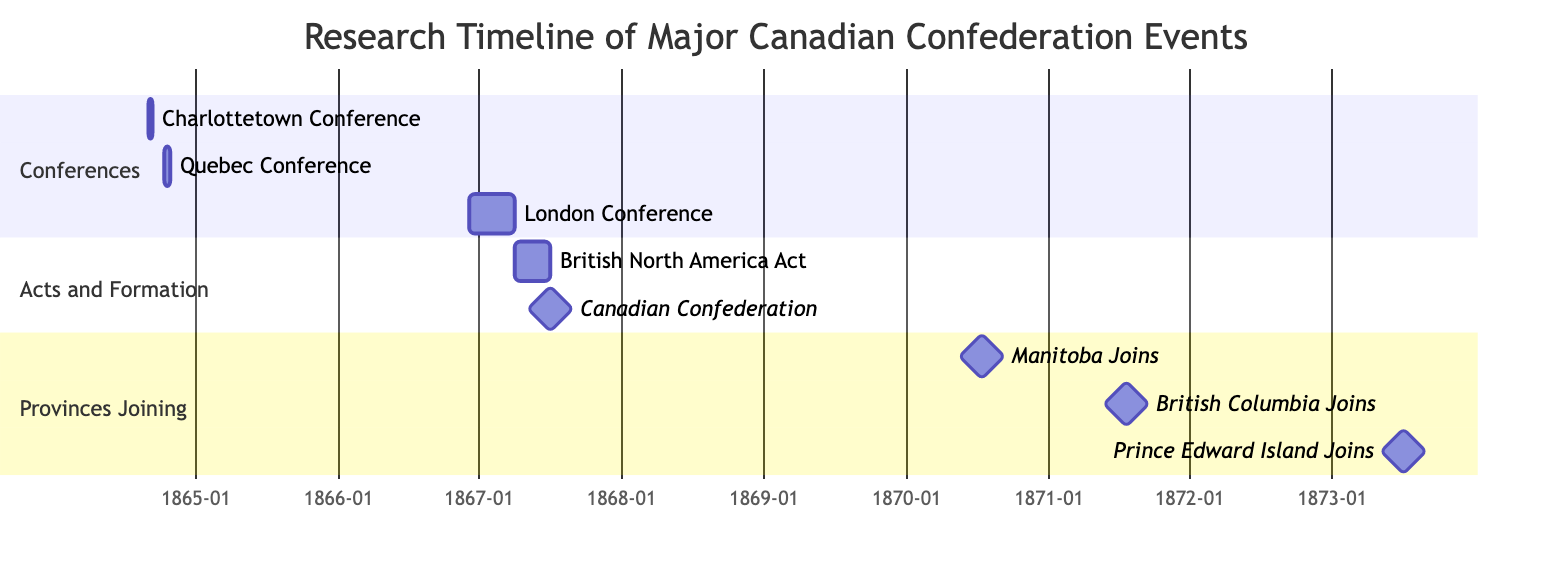What is the duration of the Charlottetown Conference? The Charlottetown Conference starts on September 1, 1864, and ends on September 9, 1864. Therefore, the duration is 9 days.
Answer: 9 days Which two events occurred in the same year, 1867? From the diagram, both the British North America Act and the Canadian Confederation took place in the year 1867.
Answer: British North America Act and Canadian Confederation How many provinces joined Confederation after its official formation in 1867? After the official formation of Confederation in 1867, three provinces joined later: Manitoba, British Columbia, and Prince Edward Island.
Answer: 3 provinces What is the milestone event that marks the official formation of Canada? The milestone event that marks the official formation of Canada is the Canadian Confederation on July 1, 1867.
Answer: Canadian Confederation Which conference directly preceded the British North America Act? The London Conference, which took place from December 4, 1866, to March 29, 1867, directly preceded the British North America Act.
Answer: London Conference What were the start and end dates of the Quebec Conference? The Quebec Conference started on October 10, 1864, and ended on October 27, 1864.
Answer: October 10, 1864 - October 27, 1864 Which province joined Confederation first after its establishment? Manitoba joined Confederation first after its establishment on July 15, 1870.
Answer: Manitoba How many total sections are there in the Gantt chart? The Gantt chart contains three sections: Conferences, Acts and Formation, and Provinces Joining, totaling three sections.
Answer: 3 sections What is the significance of the British North America Act? The British North America Act is significant as it united Ontario, Quebec, New Brunswick, and Nova Scotia into the Dominion of Canada.
Answer: United provinces into Dominion of Canada 